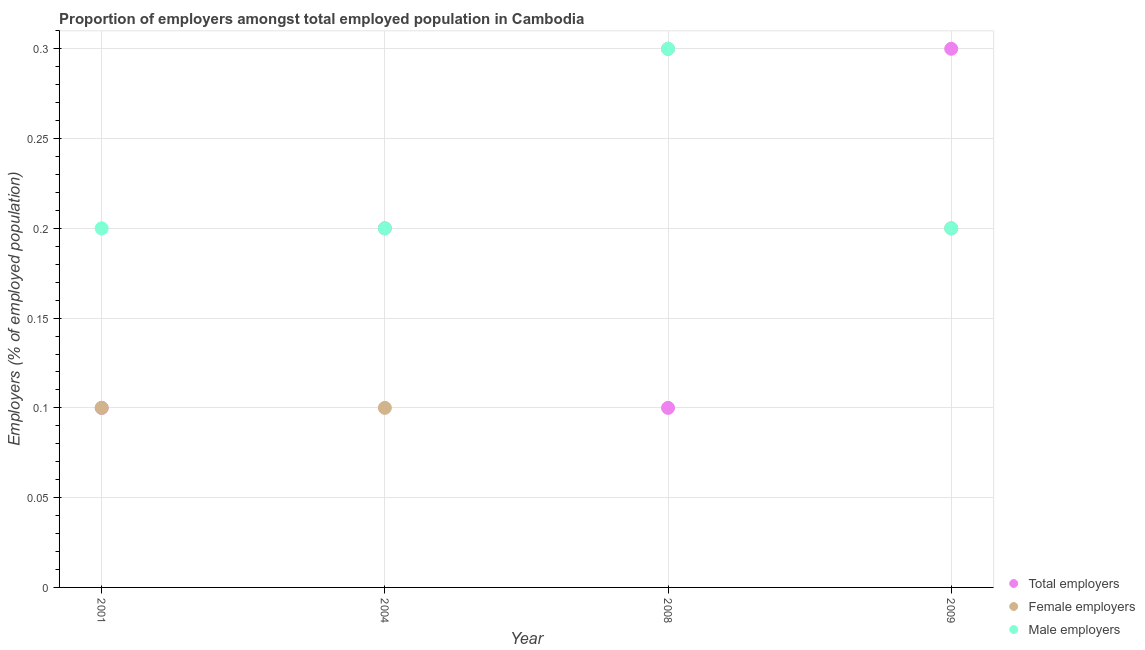Is the number of dotlines equal to the number of legend labels?
Ensure brevity in your answer.  Yes. What is the percentage of female employers in 2008?
Provide a short and direct response. 0.3. Across all years, what is the maximum percentage of male employers?
Ensure brevity in your answer.  0.3. Across all years, what is the minimum percentage of male employers?
Make the answer very short. 0.2. In which year was the percentage of male employers maximum?
Your answer should be very brief. 2008. What is the total percentage of male employers in the graph?
Offer a terse response. 0.9. What is the difference between the percentage of total employers in 2001 and that in 2004?
Ensure brevity in your answer.  -0.1. What is the difference between the percentage of total employers in 2004 and the percentage of female employers in 2008?
Your answer should be very brief. -0.1. What is the average percentage of total employers per year?
Give a very brief answer. 0.18. In the year 2008, what is the difference between the percentage of male employers and percentage of total employers?
Your answer should be compact. 0.2. In how many years, is the percentage of male employers greater than 0.29 %?
Offer a terse response. 1. What is the ratio of the percentage of female employers in 2008 to that in 2009?
Offer a very short reply. 1.5. Is the percentage of female employers in 2001 less than that in 2004?
Your answer should be compact. No. What is the difference between the highest and the second highest percentage of total employers?
Give a very brief answer. 0.1. What is the difference between the highest and the lowest percentage of female employers?
Make the answer very short. 0.2. Is the sum of the percentage of male employers in 2004 and 2008 greater than the maximum percentage of total employers across all years?
Provide a short and direct response. Yes. Is it the case that in every year, the sum of the percentage of total employers and percentage of female employers is greater than the percentage of male employers?
Ensure brevity in your answer.  No. Is the percentage of male employers strictly greater than the percentage of total employers over the years?
Your response must be concise. No. How many dotlines are there?
Offer a very short reply. 3. How many years are there in the graph?
Make the answer very short. 4. What is the difference between two consecutive major ticks on the Y-axis?
Ensure brevity in your answer.  0.05. Does the graph contain any zero values?
Make the answer very short. No. Where does the legend appear in the graph?
Provide a succinct answer. Bottom right. How are the legend labels stacked?
Give a very brief answer. Vertical. What is the title of the graph?
Provide a succinct answer. Proportion of employers amongst total employed population in Cambodia. Does "Fuel" appear as one of the legend labels in the graph?
Provide a succinct answer. No. What is the label or title of the X-axis?
Offer a terse response. Year. What is the label or title of the Y-axis?
Make the answer very short. Employers (% of employed population). What is the Employers (% of employed population) of Total employers in 2001?
Your response must be concise. 0.1. What is the Employers (% of employed population) in Female employers in 2001?
Provide a short and direct response. 0.1. What is the Employers (% of employed population) of Male employers in 2001?
Ensure brevity in your answer.  0.2. What is the Employers (% of employed population) in Total employers in 2004?
Keep it short and to the point. 0.2. What is the Employers (% of employed population) of Female employers in 2004?
Your answer should be very brief. 0.1. What is the Employers (% of employed population) of Male employers in 2004?
Provide a succinct answer. 0.2. What is the Employers (% of employed population) in Total employers in 2008?
Offer a very short reply. 0.1. What is the Employers (% of employed population) of Female employers in 2008?
Keep it short and to the point. 0.3. What is the Employers (% of employed population) in Male employers in 2008?
Your answer should be compact. 0.3. What is the Employers (% of employed population) of Total employers in 2009?
Offer a terse response. 0.3. What is the Employers (% of employed population) in Female employers in 2009?
Ensure brevity in your answer.  0.2. What is the Employers (% of employed population) in Male employers in 2009?
Offer a terse response. 0.2. Across all years, what is the maximum Employers (% of employed population) in Total employers?
Provide a succinct answer. 0.3. Across all years, what is the maximum Employers (% of employed population) in Female employers?
Your response must be concise. 0.3. Across all years, what is the maximum Employers (% of employed population) of Male employers?
Your answer should be compact. 0.3. Across all years, what is the minimum Employers (% of employed population) of Total employers?
Your response must be concise. 0.1. Across all years, what is the minimum Employers (% of employed population) in Female employers?
Offer a very short reply. 0.1. Across all years, what is the minimum Employers (% of employed population) of Male employers?
Offer a very short reply. 0.2. What is the total Employers (% of employed population) in Female employers in the graph?
Your answer should be compact. 0.7. What is the difference between the Employers (% of employed population) of Total employers in 2001 and that in 2008?
Make the answer very short. 0. What is the difference between the Employers (% of employed population) of Total employers in 2001 and that in 2009?
Provide a succinct answer. -0.2. What is the difference between the Employers (% of employed population) of Female employers in 2001 and that in 2009?
Your answer should be very brief. -0.1. What is the difference between the Employers (% of employed population) of Female employers in 2004 and that in 2008?
Your answer should be compact. -0.2. What is the difference between the Employers (% of employed population) in Male employers in 2004 and that in 2008?
Offer a terse response. -0.1. What is the difference between the Employers (% of employed population) of Total employers in 2004 and that in 2009?
Offer a very short reply. -0.1. What is the difference between the Employers (% of employed population) of Female employers in 2004 and that in 2009?
Your answer should be very brief. -0.1. What is the difference between the Employers (% of employed population) in Male employers in 2004 and that in 2009?
Your answer should be compact. 0. What is the difference between the Employers (% of employed population) in Male employers in 2008 and that in 2009?
Provide a short and direct response. 0.1. What is the difference between the Employers (% of employed population) in Total employers in 2001 and the Employers (% of employed population) in Male employers in 2004?
Offer a terse response. -0.1. What is the difference between the Employers (% of employed population) in Female employers in 2001 and the Employers (% of employed population) in Male employers in 2004?
Offer a terse response. -0.1. What is the difference between the Employers (% of employed population) in Total employers in 2001 and the Employers (% of employed population) in Male employers in 2009?
Ensure brevity in your answer.  -0.1. What is the difference between the Employers (% of employed population) of Total employers in 2004 and the Employers (% of employed population) of Female employers in 2008?
Offer a very short reply. -0.1. What is the difference between the Employers (% of employed population) in Total employers in 2008 and the Employers (% of employed population) in Female employers in 2009?
Your answer should be compact. -0.1. What is the average Employers (% of employed population) in Total employers per year?
Ensure brevity in your answer.  0.17. What is the average Employers (% of employed population) in Female employers per year?
Keep it short and to the point. 0.17. What is the average Employers (% of employed population) in Male employers per year?
Make the answer very short. 0.23. In the year 2001, what is the difference between the Employers (% of employed population) in Total employers and Employers (% of employed population) in Male employers?
Your answer should be very brief. -0.1. In the year 2004, what is the difference between the Employers (% of employed population) of Total employers and Employers (% of employed population) of Female employers?
Keep it short and to the point. 0.1. In the year 2004, what is the difference between the Employers (% of employed population) in Total employers and Employers (% of employed population) in Male employers?
Make the answer very short. 0. In the year 2008, what is the difference between the Employers (% of employed population) of Total employers and Employers (% of employed population) of Female employers?
Offer a terse response. -0.2. In the year 2008, what is the difference between the Employers (% of employed population) of Female employers and Employers (% of employed population) of Male employers?
Your answer should be very brief. 0. In the year 2009, what is the difference between the Employers (% of employed population) in Female employers and Employers (% of employed population) in Male employers?
Offer a very short reply. 0. What is the ratio of the Employers (% of employed population) in Total employers in 2001 to that in 2004?
Give a very brief answer. 0.5. What is the ratio of the Employers (% of employed population) in Total employers in 2001 to that in 2008?
Offer a very short reply. 1. What is the ratio of the Employers (% of employed population) of Female employers in 2001 to that in 2008?
Make the answer very short. 0.33. What is the ratio of the Employers (% of employed population) of Female employers in 2001 to that in 2009?
Keep it short and to the point. 0.5. What is the ratio of the Employers (% of employed population) of Female employers in 2004 to that in 2008?
Provide a succinct answer. 0.33. What is the ratio of the Employers (% of employed population) in Total employers in 2004 to that in 2009?
Offer a very short reply. 0.67. What is the ratio of the Employers (% of employed population) in Female employers in 2004 to that in 2009?
Provide a succinct answer. 0.5. What is the ratio of the Employers (% of employed population) of Male employers in 2004 to that in 2009?
Your answer should be compact. 1. What is the ratio of the Employers (% of employed population) of Female employers in 2008 to that in 2009?
Make the answer very short. 1.5. What is the difference between the highest and the second highest Employers (% of employed population) of Total employers?
Ensure brevity in your answer.  0.1. What is the difference between the highest and the lowest Employers (% of employed population) in Total employers?
Your response must be concise. 0.2. What is the difference between the highest and the lowest Employers (% of employed population) in Female employers?
Give a very brief answer. 0.2. What is the difference between the highest and the lowest Employers (% of employed population) of Male employers?
Provide a succinct answer. 0.1. 